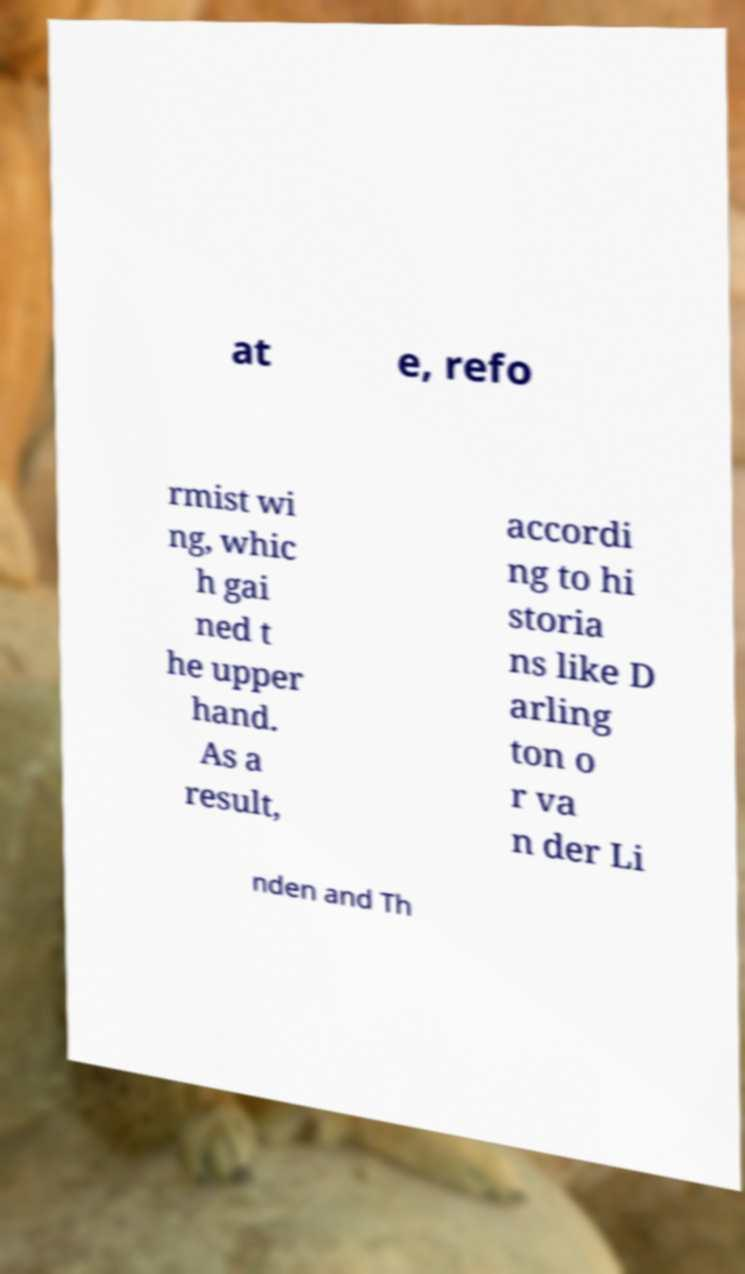I need the written content from this picture converted into text. Can you do that? at e, refo rmist wi ng, whic h gai ned t he upper hand. As a result, accordi ng to hi storia ns like D arling ton o r va n der Li nden and Th 